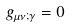<formula> <loc_0><loc_0><loc_500><loc_500>g _ { \mu \nu ; \gamma } = 0</formula> 